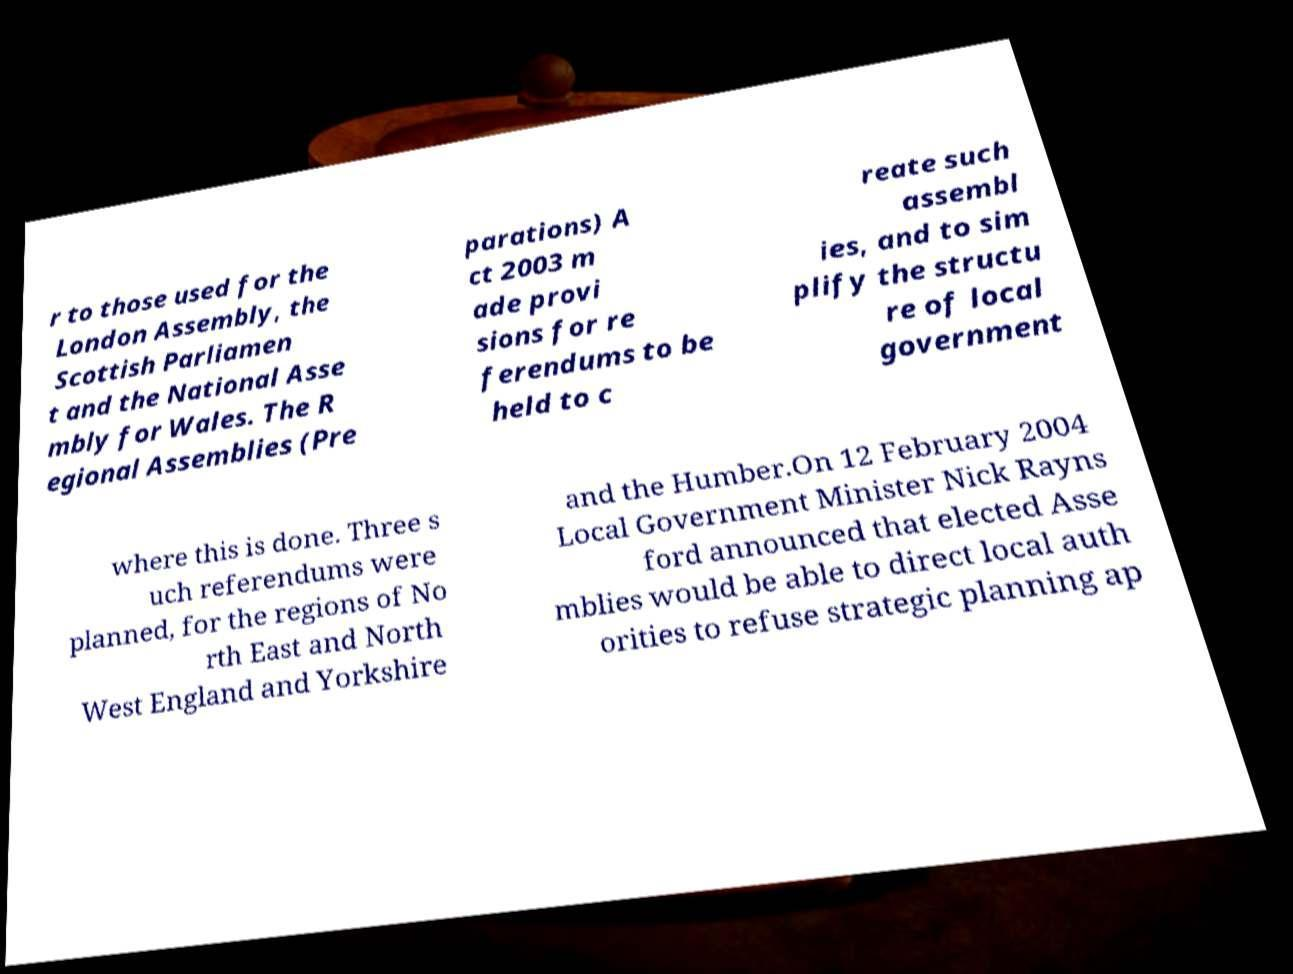For documentation purposes, I need the text within this image transcribed. Could you provide that? r to those used for the London Assembly, the Scottish Parliamen t and the National Asse mbly for Wales. The R egional Assemblies (Pre parations) A ct 2003 m ade provi sions for re ferendums to be held to c reate such assembl ies, and to sim plify the structu re of local government where this is done. Three s uch referendums were planned, for the regions of No rth East and North West England and Yorkshire and the Humber.On 12 February 2004 Local Government Minister Nick Rayns ford announced that elected Asse mblies would be able to direct local auth orities to refuse strategic planning ap 